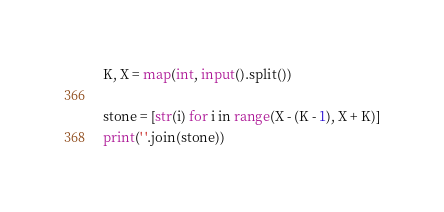Convert code to text. <code><loc_0><loc_0><loc_500><loc_500><_Python_>K, X = map(int, input().split())

stone = [str(i) for i in range(X - (K - 1), X + K)]
print(' '.join(stone))</code> 